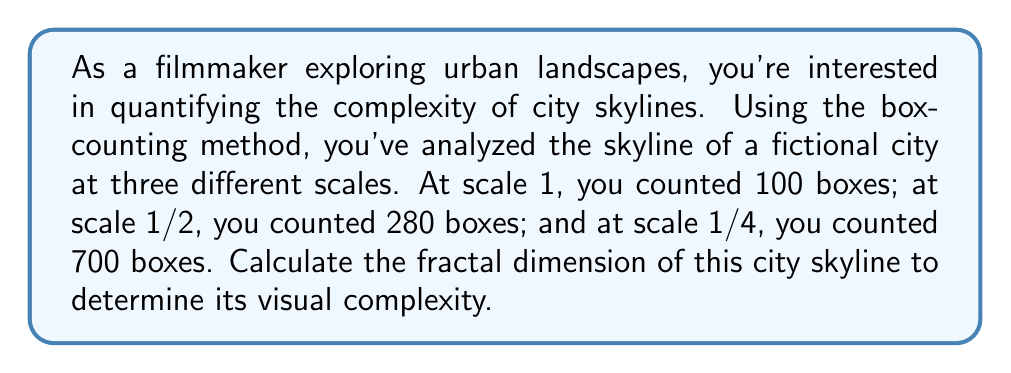Teach me how to tackle this problem. To calculate the fractal dimension using the box-counting method, we'll follow these steps:

1) The box-counting dimension is defined as:

   $$D = \lim_{\epsilon \to 0} \frac{\log N(\epsilon)}{\log(1/\epsilon)}$$

   where $N(\epsilon)$ is the number of boxes of side length $\epsilon$ needed to cover the object.

2) We have three data points:
   - Scale 1: $\epsilon_1 = 1$, $N(\epsilon_1) = 100$
   - Scale 1/2: $\epsilon_2 = 1/2$, $N(\epsilon_2) = 280$
   - Scale 1/4: $\epsilon_3 = 1/4$, $N(\epsilon_3) = 700$

3) We can estimate D by calculating the slope of the line in a log-log plot:

   $$D \approx \frac{\log(N(\epsilon_2)) - \log(N(\epsilon_1))}{\log(1/\epsilon_2) - \log(1/\epsilon_1)}$$

4) Let's calculate using the first two data points:

   $$D \approx \frac{\log(280) - \log(100)}{\log(2) - \log(1)} = \frac{\log(2.8)}{\log(2)} \approx 1.4854$$

5) We can also calculate using the first and third data points:

   $$D \approx \frac{\log(700) - \log(100)}{\log(4) - \log(1)} = \frac{\log(7)}{\log(4)} \approx 1.4036$$

6) Taking the average of these two estimates:

   $$D \approx \frac{1.4854 + 1.4036}{2} \approx 1.4445$$

This fractal dimension between 1 and 2 indicates a skyline with significant complexity, more intricate than a simple line (dimension 1) but not as complex as a fully filled plane (dimension 2).
Answer: $D \approx 1.4445$ 